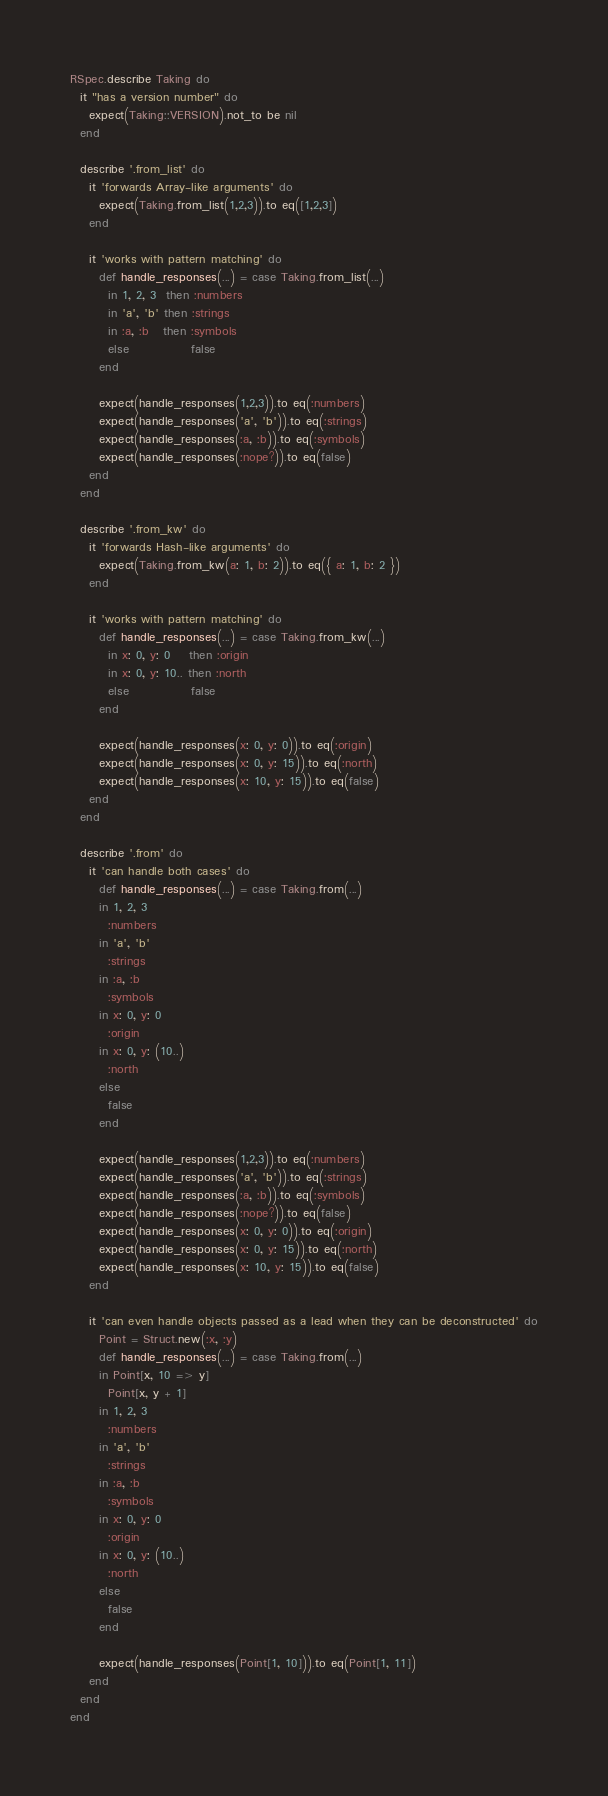Convert code to text. <code><loc_0><loc_0><loc_500><loc_500><_Ruby_>RSpec.describe Taking do
  it "has a version number" do
    expect(Taking::VERSION).not_to be nil
  end

  describe '.from_list' do
    it 'forwards Array-like arguments' do
      expect(Taking.from_list(1,2,3)).to eq([1,2,3])
    end

    it 'works with pattern matching' do
      def handle_responses(...) = case Taking.from_list(...)
        in 1, 2, 3  then :numbers
        in 'a', 'b' then :strings
        in :a, :b   then :symbols
        else             false
      end

      expect(handle_responses(1,2,3)).to eq(:numbers)
      expect(handle_responses('a', 'b')).to eq(:strings)
      expect(handle_responses(:a, :b)).to eq(:symbols)
      expect(handle_responses(:nope?)).to eq(false)
    end
  end

  describe '.from_kw' do
    it 'forwards Hash-like arguments' do
      expect(Taking.from_kw(a: 1, b: 2)).to eq({ a: 1, b: 2 })
    end

    it 'works with pattern matching' do
      def handle_responses(...) = case Taking.from_kw(...)
        in x: 0, y: 0    then :origin
        in x: 0, y: 10.. then :north
        else             false
      end

      expect(handle_responses(x: 0, y: 0)).to eq(:origin)
      expect(handle_responses(x: 0, y: 15)).to eq(:north)
      expect(handle_responses(x: 10, y: 15)).to eq(false)
    end
  end

  describe '.from' do
    it 'can handle both cases' do
      def handle_responses(...) = case Taking.from(...)
      in 1, 2, 3
        :numbers
      in 'a', 'b'
        :strings
      in :a, :b
        :symbols
      in x: 0, y: 0
        :origin
      in x: 0, y: (10..)
        :north
      else
        false
      end

      expect(handle_responses(1,2,3)).to eq(:numbers)
      expect(handle_responses('a', 'b')).to eq(:strings)
      expect(handle_responses(:a, :b)).to eq(:symbols)
      expect(handle_responses(:nope?)).to eq(false)
      expect(handle_responses(x: 0, y: 0)).to eq(:origin)
      expect(handle_responses(x: 0, y: 15)).to eq(:north)
      expect(handle_responses(x: 10, y: 15)).to eq(false)
    end

    it 'can even handle objects passed as a lead when they can be deconstructed' do
      Point = Struct.new(:x, :y)
      def handle_responses(...) = case Taking.from(...)
      in Point[x, 10 => y]
        Point[x, y + 1]
      in 1, 2, 3
        :numbers
      in 'a', 'b'
        :strings
      in :a, :b
        :symbols
      in x: 0, y: 0
        :origin
      in x: 0, y: (10..)
        :north
      else
        false
      end

      expect(handle_responses(Point[1, 10])).to eq(Point[1, 11])
    end
  end
end
</code> 